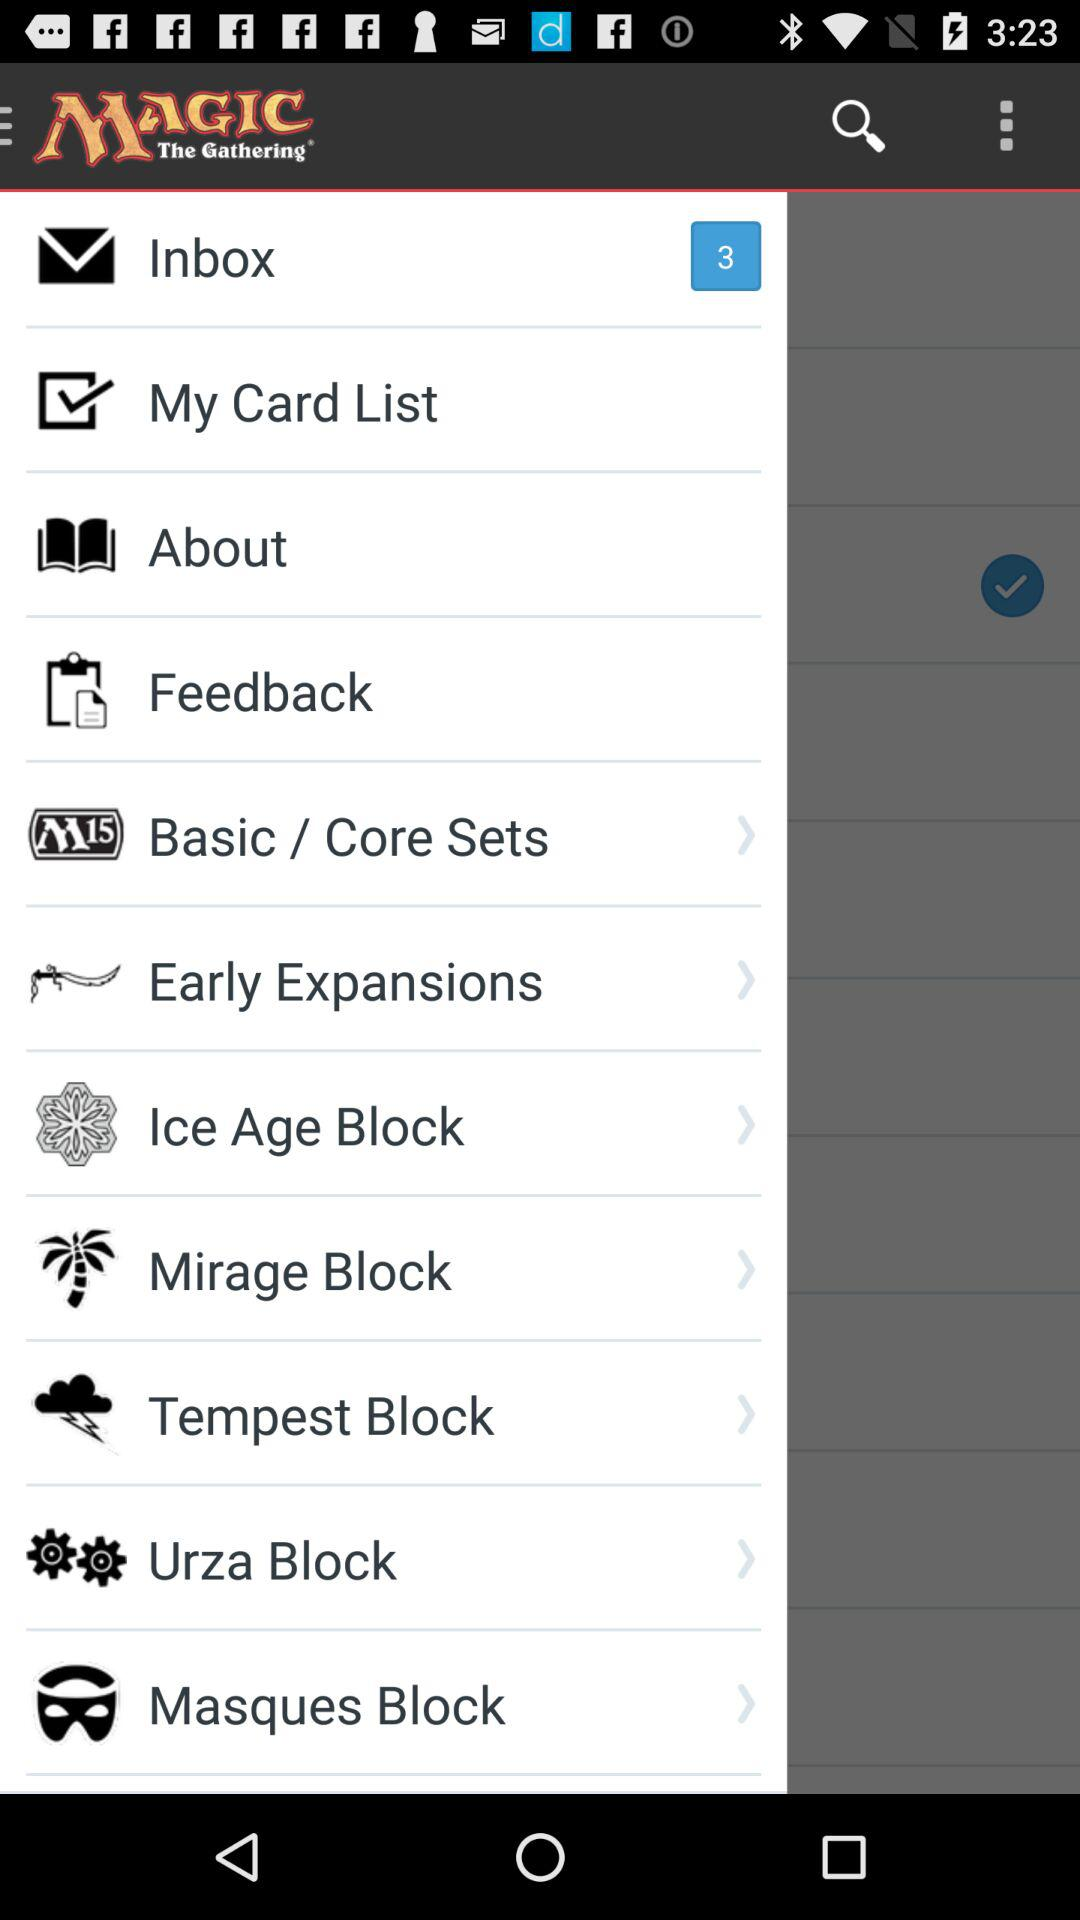What is the name of the application? The name of the application is "MAGIC The Gathering". 